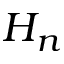<formula> <loc_0><loc_0><loc_500><loc_500>H _ { n }</formula> 